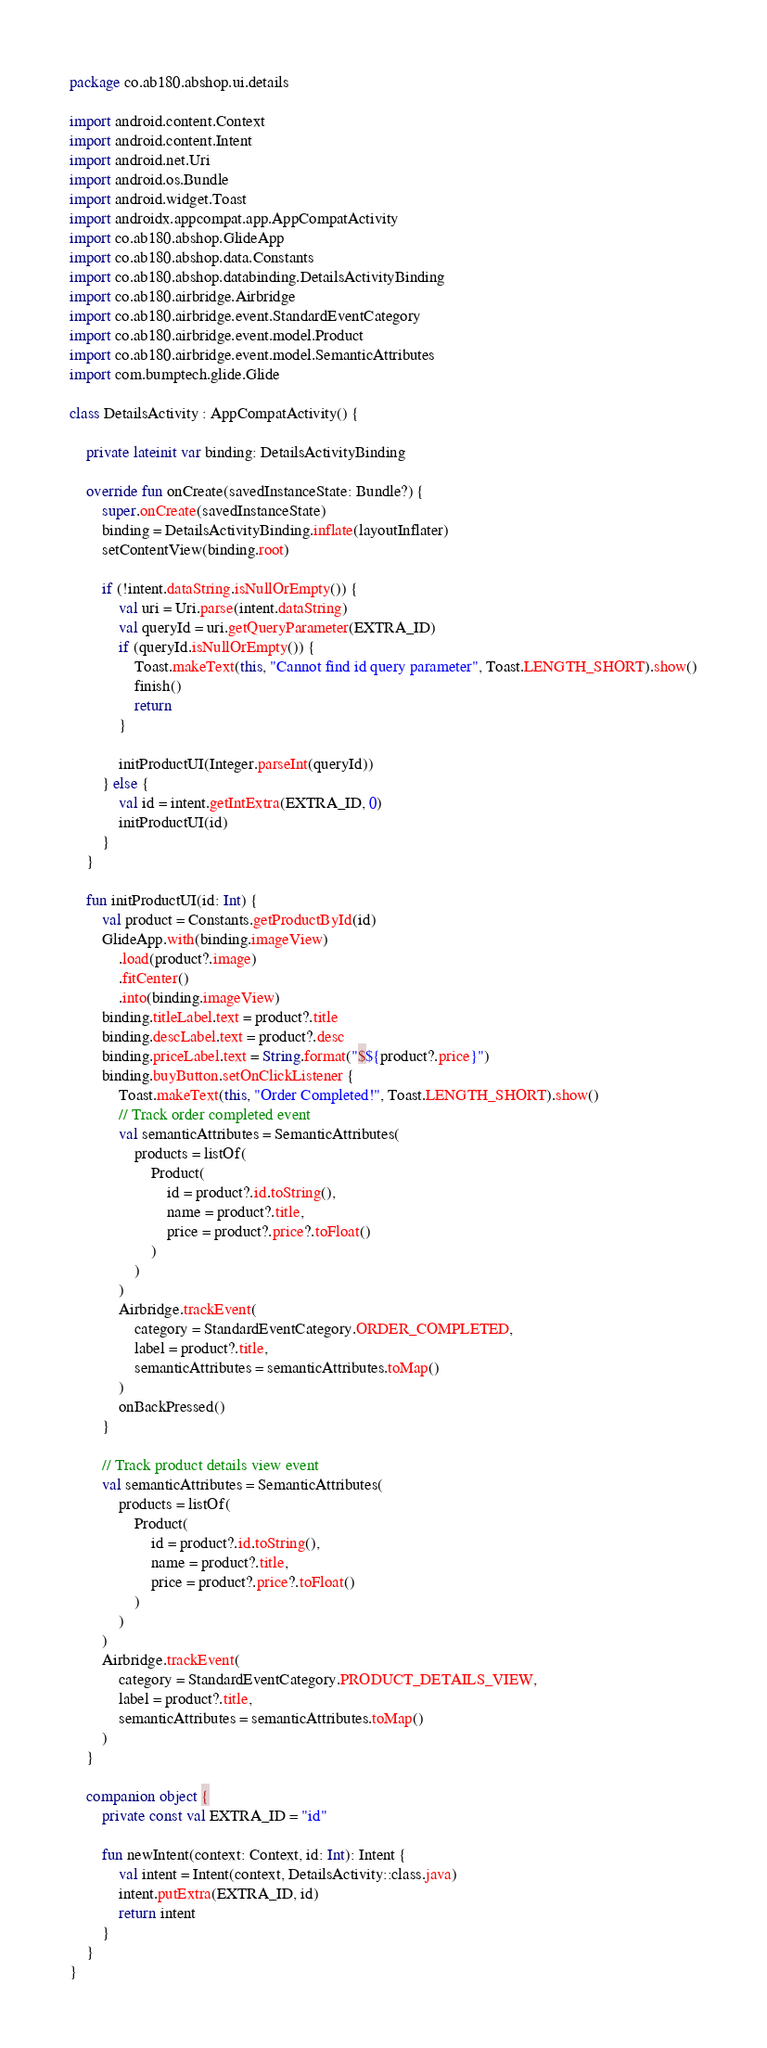<code> <loc_0><loc_0><loc_500><loc_500><_Kotlin_>package co.ab180.abshop.ui.details

import android.content.Context
import android.content.Intent
import android.net.Uri
import android.os.Bundle
import android.widget.Toast
import androidx.appcompat.app.AppCompatActivity
import co.ab180.abshop.GlideApp
import co.ab180.abshop.data.Constants
import co.ab180.abshop.databinding.DetailsActivityBinding
import co.ab180.airbridge.Airbridge
import co.ab180.airbridge.event.StandardEventCategory
import co.ab180.airbridge.event.model.Product
import co.ab180.airbridge.event.model.SemanticAttributes
import com.bumptech.glide.Glide

class DetailsActivity : AppCompatActivity() {

    private lateinit var binding: DetailsActivityBinding

    override fun onCreate(savedInstanceState: Bundle?) {
        super.onCreate(savedInstanceState)
        binding = DetailsActivityBinding.inflate(layoutInflater)
        setContentView(binding.root)

        if (!intent.dataString.isNullOrEmpty()) {
            val uri = Uri.parse(intent.dataString)
            val queryId = uri.getQueryParameter(EXTRA_ID)
            if (queryId.isNullOrEmpty()) {
                Toast.makeText(this, "Cannot find id query parameter", Toast.LENGTH_SHORT).show()
                finish()
                return
            }

            initProductUI(Integer.parseInt(queryId))
        } else {
            val id = intent.getIntExtra(EXTRA_ID, 0)
            initProductUI(id)
        }
    }

    fun initProductUI(id: Int) {
        val product = Constants.getProductById(id)
        GlideApp.with(binding.imageView)
            .load(product?.image)
            .fitCenter()
            .into(binding.imageView)
        binding.titleLabel.text = product?.title
        binding.descLabel.text = product?.desc
        binding.priceLabel.text = String.format("$${product?.price}")
        binding.buyButton.setOnClickListener {
            Toast.makeText(this, "Order Completed!", Toast.LENGTH_SHORT).show()
            // Track order completed event
            val semanticAttributes = SemanticAttributes(
                products = listOf(
                    Product(
                        id = product?.id.toString(),
                        name = product?.title,
                        price = product?.price?.toFloat()
                    )
                )
            )
            Airbridge.trackEvent(
                category = StandardEventCategory.ORDER_COMPLETED,
                label = product?.title,
                semanticAttributes = semanticAttributes.toMap()
            )
            onBackPressed()
        }

        // Track product details view event
        val semanticAttributes = SemanticAttributes(
            products = listOf(
                Product(
                    id = product?.id.toString(),
                    name = product?.title,
                    price = product?.price?.toFloat()
                )
            )
        )
        Airbridge.trackEvent(
            category = StandardEventCategory.PRODUCT_DETAILS_VIEW,
            label = product?.title,
            semanticAttributes = semanticAttributes.toMap()
        )
    }

    companion object {
        private const val EXTRA_ID = "id"

        fun newIntent(context: Context, id: Int): Intent {
            val intent = Intent(context, DetailsActivity::class.java)
            intent.putExtra(EXTRA_ID, id)
            return intent
        }
    }
}</code> 